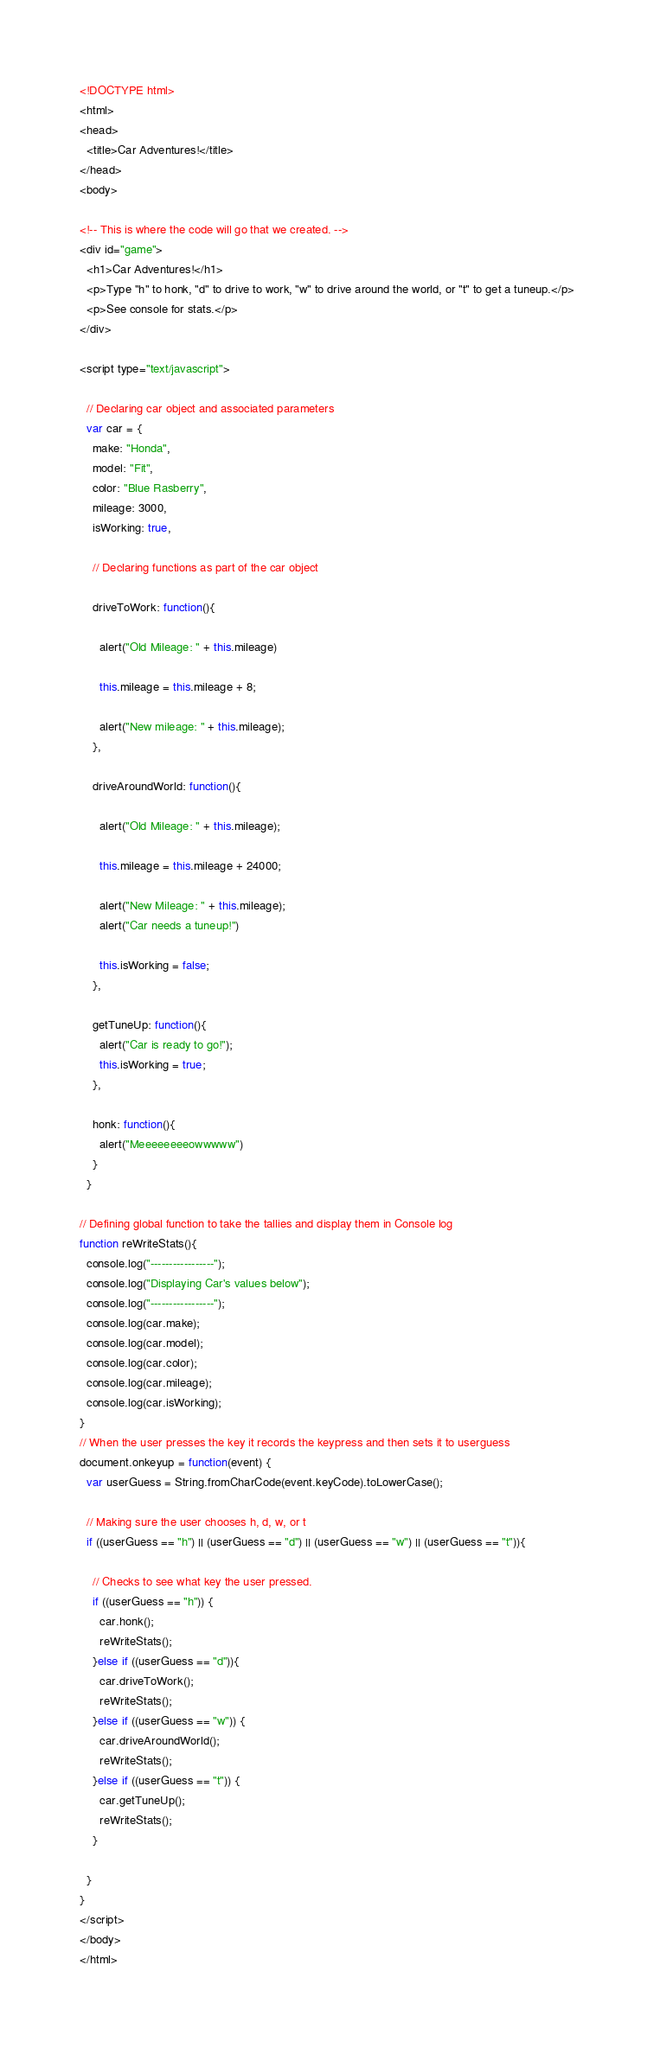Convert code to text. <code><loc_0><loc_0><loc_500><loc_500><_HTML_><!DOCTYPE html>
<html>
<head>
  <title>Car Adventures!</title>
</head>
<body>

<!-- This is where the code will go that we created. -->
<div id="game">
  <h1>Car Adventures!</h1>
  <p>Type "h" to honk, "d" to drive to work, "w" to drive around the world, or "t" to get a tuneup.</p>
  <p>See console for stats.</p>
</div>

<script type="text/javascript">

  // Declaring car object and associated parameters
  var car = {
    make: "Honda",
    model: "Fit",
    color: "Blue Rasberry",
    mileage: 3000,
    isWorking: true,

    // Declaring functions as part of the car object

    driveToWork: function(){

      alert("Old Mileage: " + this.mileage)
      
      this.mileage = this.mileage + 8;
      
      alert("New mileage: " + this.mileage);
    },

    driveAroundWorld: function(){

      alert("Old Mileage: " + this.mileage);

      this.mileage = this.mileage + 24000;

      alert("New Mileage: " + this.mileage);
      alert("Car needs a tuneup!")

      this.isWorking = false;
    },

    getTuneUp: function(){
      alert("Car is ready to go!");
      this.isWorking = true;
    },

    honk: function(){
      alert("Meeeeeeeeowwwww")
    } 
  }

// Defining global function to take the tallies and display them in Console log
function reWriteStats(){
  console.log("-----------------");
  console.log("Displaying Car's values below");
  console.log("-----------------");
  console.log(car.make);
  console.log(car.model);
  console.log(car.color);
  console.log(car.mileage);
  console.log(car.isWorking);
}
// When the user presses the key it records the keypress and then sets it to userguess
document.onkeyup = function(event) {
  var userGuess = String.fromCharCode(event.keyCode).toLowerCase();

  // Making sure the user chooses h, d, w, or t
  if ((userGuess == "h") || (userGuess == "d") || (userGuess == "w") || (userGuess == "t")){

    // Checks to see what key the user pressed. 
    if ((userGuess == "h")) {
      car.honk();
      reWriteStats();
    }else if ((userGuess == "d")){
      car.driveToWork();
      reWriteStats();
    }else if ((userGuess == "w")) { 
      car.driveAroundWorld();
      reWriteStats();
    }else if ((userGuess == "t")) {
      car.getTuneUp();
      reWriteStats();
    }  

  }
}
</script>
</body>
</html></code> 